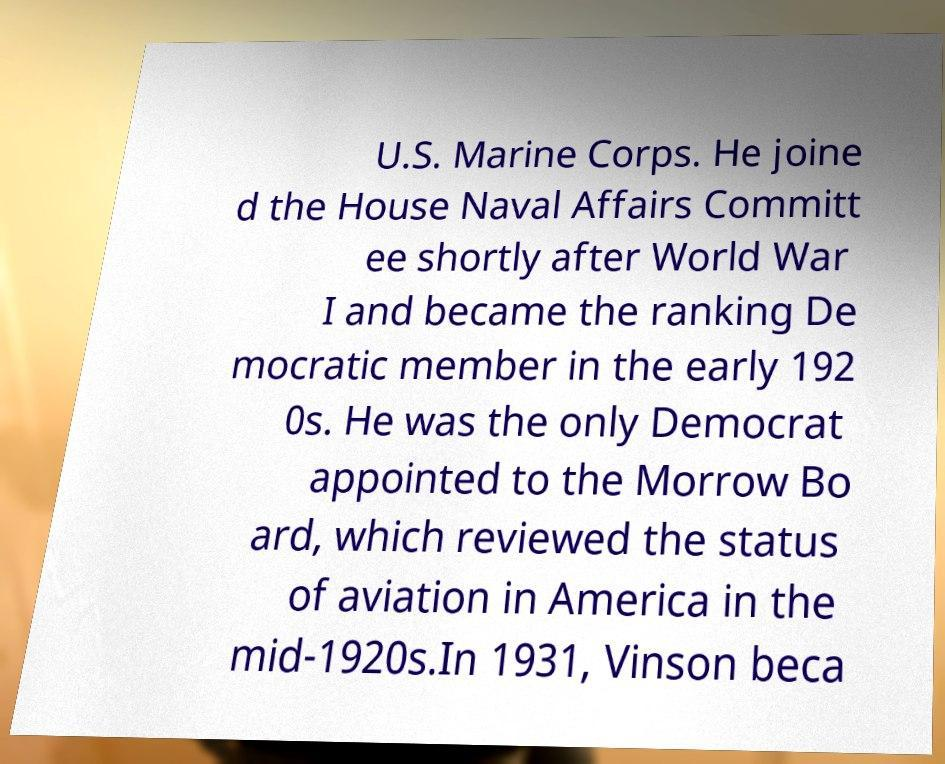Can you read and provide the text displayed in the image?This photo seems to have some interesting text. Can you extract and type it out for me? U.S. Marine Corps. He joine d the House Naval Affairs Committ ee shortly after World War I and became the ranking De mocratic member in the early 192 0s. He was the only Democrat appointed to the Morrow Bo ard, which reviewed the status of aviation in America in the mid-1920s.In 1931, Vinson beca 